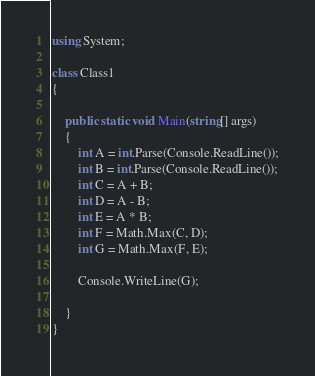<code> <loc_0><loc_0><loc_500><loc_500><_C#_>using System;

class Class1
{

    public static void Main(string[] args)
    {
        int A = int.Parse(Console.ReadLine());
        int B = int.Parse(Console.ReadLine());
        int C = A + B;
        int D = A - B;
        int E = A * B;
        int F = Math.Max(C, D);
        int G = Math.Max(F, E);

        Console.WriteLine(G);
        
    }
}</code> 